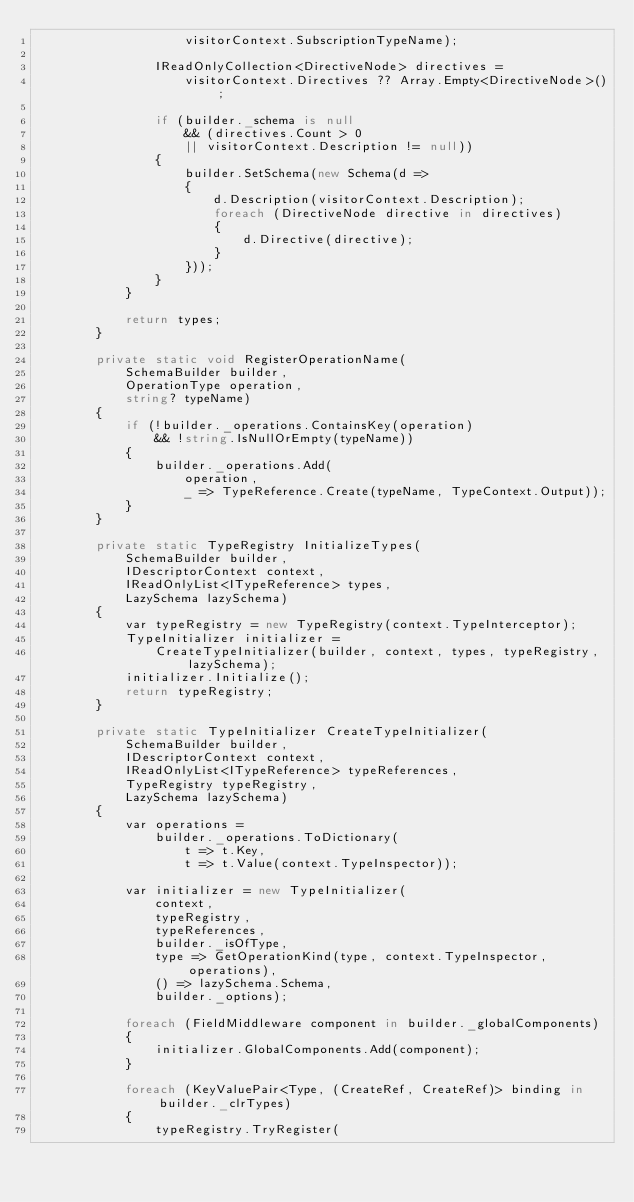<code> <loc_0><loc_0><loc_500><loc_500><_C#_>                    visitorContext.SubscriptionTypeName);

                IReadOnlyCollection<DirectiveNode> directives =
                    visitorContext.Directives ?? Array.Empty<DirectiveNode>();

                if (builder._schema is null
                    && (directives.Count > 0
                    || visitorContext.Description != null))
                {
                    builder.SetSchema(new Schema(d =>
                    {
                        d.Description(visitorContext.Description);
                        foreach (DirectiveNode directive in directives)
                        {
                            d.Directive(directive);
                        }
                    }));
                }
            }

            return types;
        }

        private static void RegisterOperationName(
            SchemaBuilder builder,
            OperationType operation,
            string? typeName)
        {
            if (!builder._operations.ContainsKey(operation)
                && !string.IsNullOrEmpty(typeName))
            {
                builder._operations.Add(
                    operation,
                    _ => TypeReference.Create(typeName, TypeContext.Output));
            }
        }

        private static TypeRegistry InitializeTypes(
            SchemaBuilder builder,
            IDescriptorContext context,
            IReadOnlyList<ITypeReference> types,
            LazySchema lazySchema)
        {
            var typeRegistry = new TypeRegistry(context.TypeInterceptor);
            TypeInitializer initializer =
                CreateTypeInitializer(builder, context, types, typeRegistry, lazySchema);
            initializer.Initialize();
            return typeRegistry;
        }

        private static TypeInitializer CreateTypeInitializer(
            SchemaBuilder builder,
            IDescriptorContext context,
            IReadOnlyList<ITypeReference> typeReferences,
            TypeRegistry typeRegistry,
            LazySchema lazySchema)
        {
            var operations =
                builder._operations.ToDictionary(
                    t => t.Key,
                    t => t.Value(context.TypeInspector));

            var initializer = new TypeInitializer(
                context,
                typeRegistry,
                typeReferences,
                builder._isOfType,
                type => GetOperationKind(type, context.TypeInspector, operations),
                () => lazySchema.Schema,
                builder._options);

            foreach (FieldMiddleware component in builder._globalComponents)
            {
                initializer.GlobalComponents.Add(component);
            }

            foreach (KeyValuePair<Type, (CreateRef, CreateRef)> binding in builder._clrTypes)
            {
                typeRegistry.TryRegister(</code> 